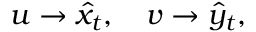Convert formula to latex. <formula><loc_0><loc_0><loc_500><loc_500>u \rightarrow \hat { x } _ { t } , \quad v \rightarrow \hat { y } _ { t } ,</formula> 